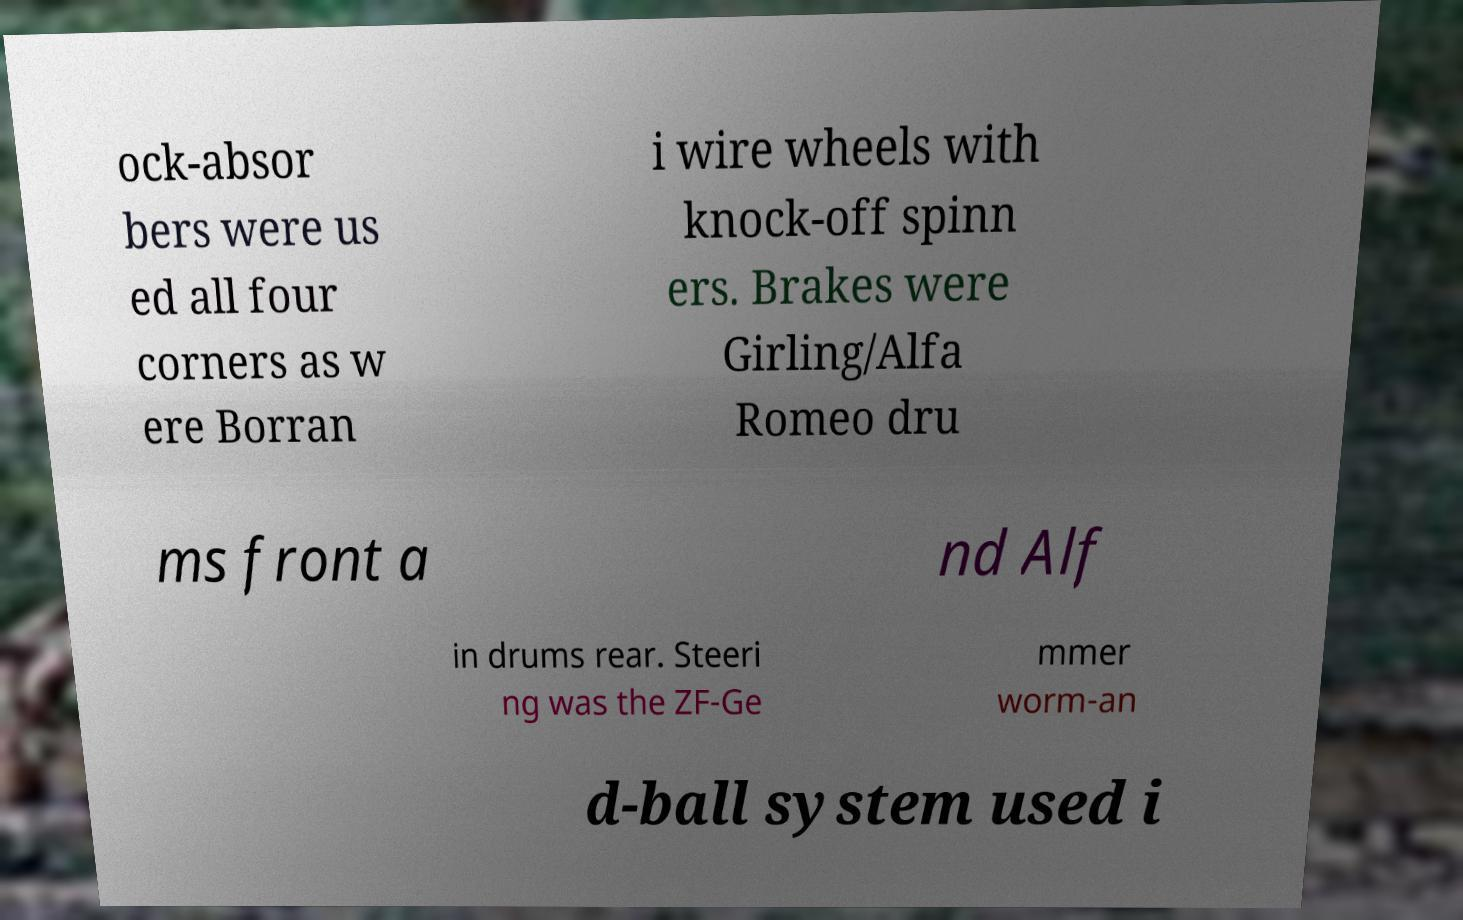What messages or text are displayed in this image? I need them in a readable, typed format. ock-absor bers were us ed all four corners as w ere Borran i wire wheels with knock-off spinn ers. Brakes were Girling/Alfa Romeo dru ms front a nd Alf in drums rear. Steeri ng was the ZF-Ge mmer worm-an d-ball system used i 